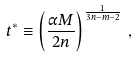Convert formula to latex. <formula><loc_0><loc_0><loc_500><loc_500>t ^ { * } \equiv \left ( \frac { \alpha M } { 2 n } \right ) ^ { \frac { 1 } { 3 n - m - 2 } } \, ,</formula> 